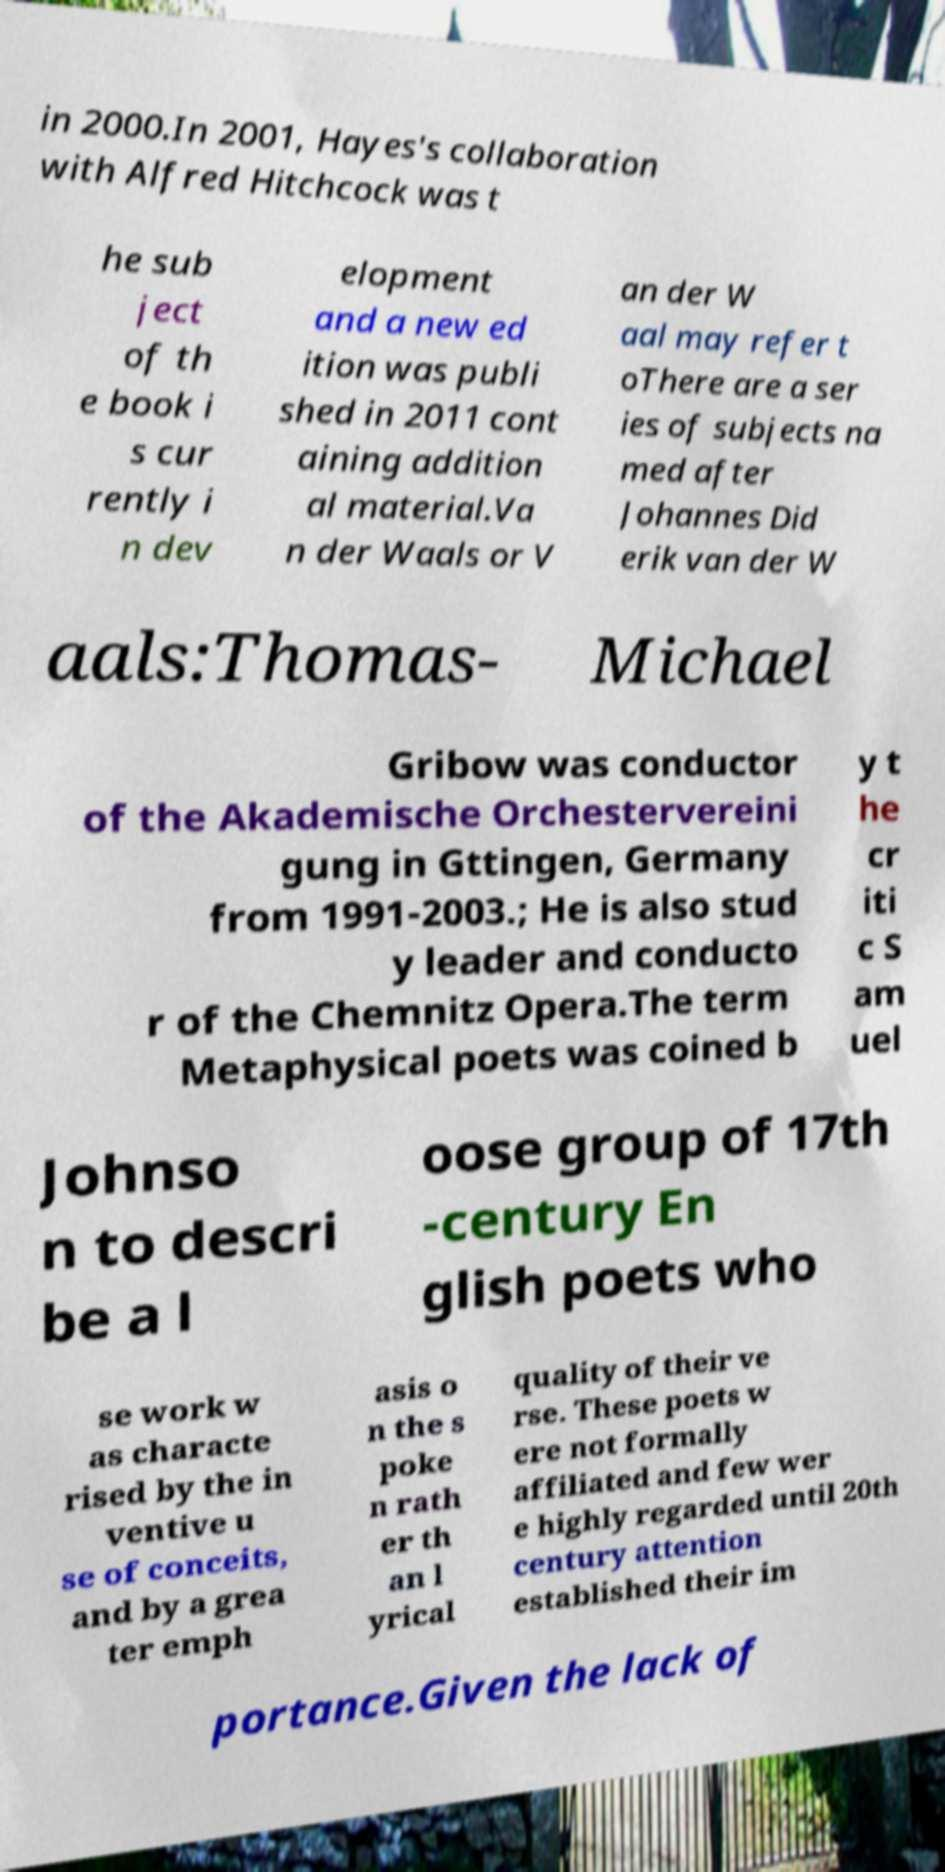Can you read and provide the text displayed in the image?This photo seems to have some interesting text. Can you extract and type it out for me? in 2000.In 2001, Hayes's collaboration with Alfred Hitchcock was t he sub ject of th e book i s cur rently i n dev elopment and a new ed ition was publi shed in 2011 cont aining addition al material.Va n der Waals or V an der W aal may refer t oThere are a ser ies of subjects na med after Johannes Did erik van der W aals:Thomas- Michael Gribow was conductor of the Akademische Orchestervereini gung in Gttingen, Germany from 1991-2003.; He is also stud y leader and conducto r of the Chemnitz Opera.The term Metaphysical poets was coined b y t he cr iti c S am uel Johnso n to descri be a l oose group of 17th -century En glish poets who se work w as characte rised by the in ventive u se of conceits, and by a grea ter emph asis o n the s poke n rath er th an l yrical quality of their ve rse. These poets w ere not formally affiliated and few wer e highly regarded until 20th century attention established their im portance.Given the lack of 